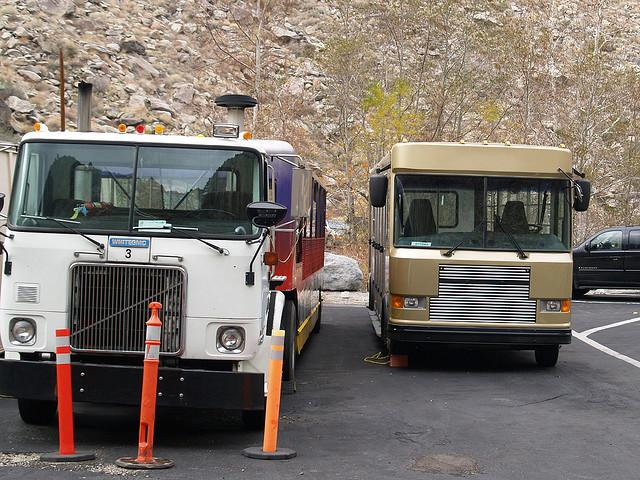What are these vehicles called? buses 